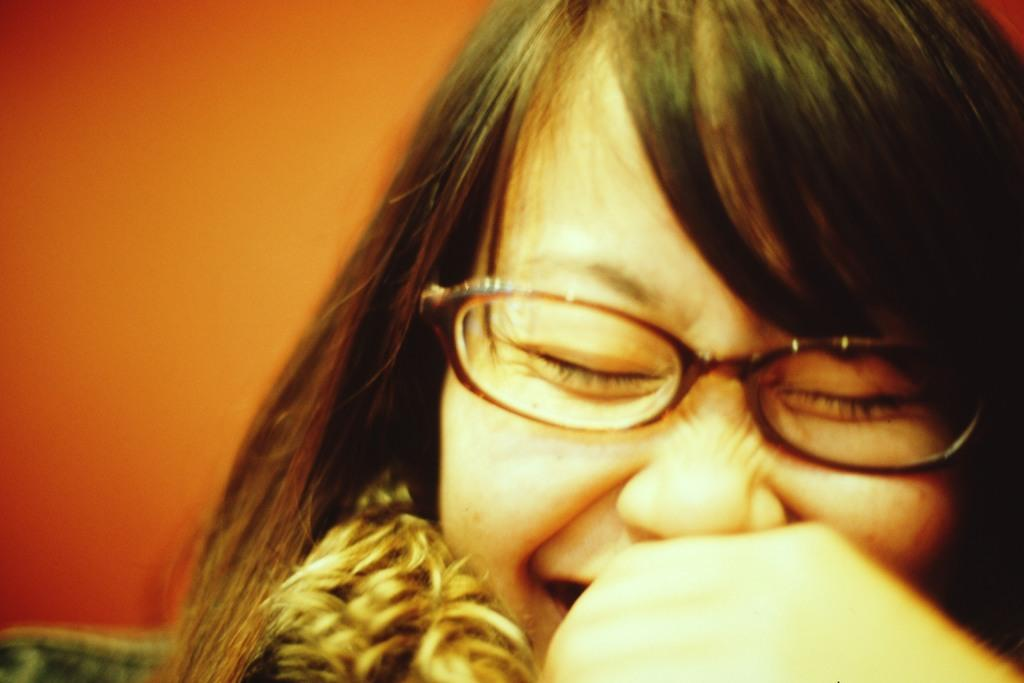Who is present in the image? There is a woman in the image. What part of the woman's body is controlling the image? The image is a still photograph and does not involve any body parts controlling it. 